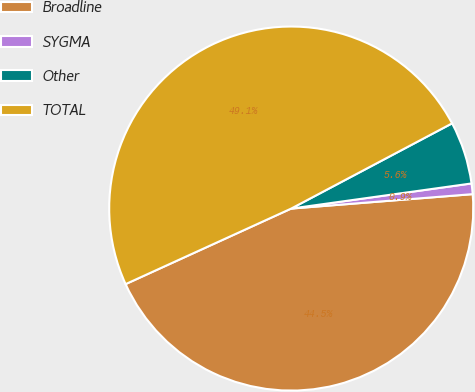<chart> <loc_0><loc_0><loc_500><loc_500><pie_chart><fcel>Broadline<fcel>SYGMA<fcel>Other<fcel>TOTAL<nl><fcel>44.45%<fcel>0.94%<fcel>5.55%<fcel>49.06%<nl></chart> 